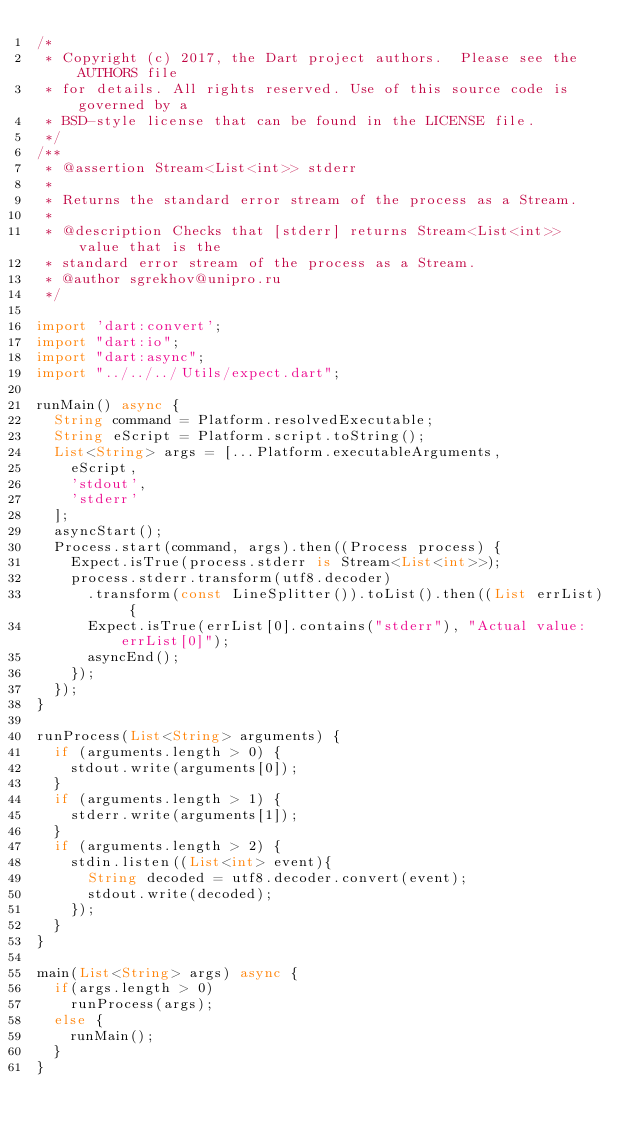Convert code to text. <code><loc_0><loc_0><loc_500><loc_500><_Dart_>/*
 * Copyright (c) 2017, the Dart project authors.  Please see the AUTHORS file
 * for details. All rights reserved. Use of this source code is governed by a
 * BSD-style license that can be found in the LICENSE file.
 */
/**
 * @assertion Stream<List<int>> stderr
 *
 * Returns the standard error stream of the process as a Stream.
 *
 * @description Checks that [stderr] returns Stream<List<int>> value that is the
 * standard error stream of the process as a Stream.
 * @author sgrekhov@unipro.ru
 */

import 'dart:convert';
import "dart:io";
import "dart:async";
import "../../../Utils/expect.dart";

runMain() async {
  String command = Platform.resolvedExecutable;
  String eScript = Platform.script.toString();
  List<String> args = [...Platform.executableArguments,
    eScript,
    'stdout',
    'stderr'
  ];
  asyncStart();
  Process.start(command, args).then((Process process) {
    Expect.isTrue(process.stderr is Stream<List<int>>);
    process.stderr.transform(utf8.decoder)
      .transform(const LineSplitter()).toList().then((List errList) {
      Expect.isTrue(errList[0].contains("stderr"), "Actual value: errList[0]");
      asyncEnd();
    });
  });
}

runProcess(List<String> arguments) {
  if (arguments.length > 0) {
    stdout.write(arguments[0]);
  }
  if (arguments.length > 1) {
    stderr.write(arguments[1]);
  }
  if (arguments.length > 2) {
    stdin.listen((List<int> event){
      String decoded = utf8.decoder.convert(event);
      stdout.write(decoded);
    });
  }
}

main(List<String> args) async {
  if(args.length > 0)
    runProcess(args);
  else {
    runMain();
  }
}
</code> 